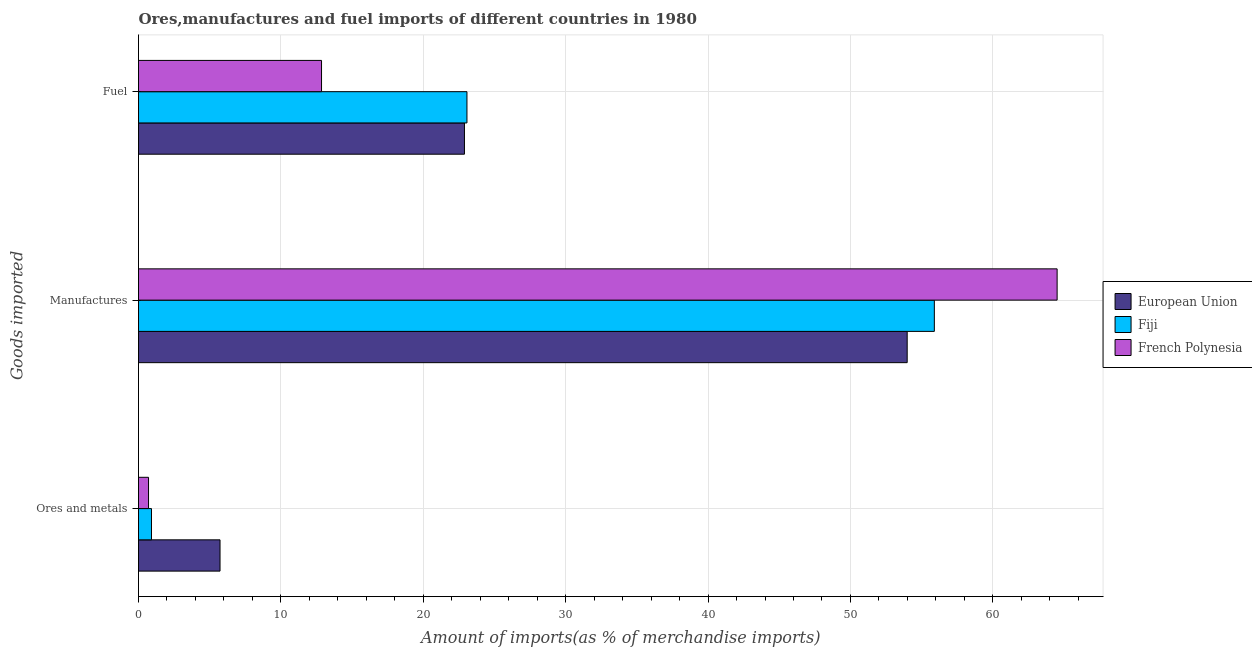How many groups of bars are there?
Your answer should be very brief. 3. Are the number of bars per tick equal to the number of legend labels?
Offer a very short reply. Yes. What is the label of the 3rd group of bars from the top?
Your answer should be very brief. Ores and metals. What is the percentage of fuel imports in Fiji?
Ensure brevity in your answer.  23.07. Across all countries, what is the maximum percentage of ores and metals imports?
Offer a terse response. 5.72. Across all countries, what is the minimum percentage of ores and metals imports?
Provide a succinct answer. 0.7. In which country was the percentage of ores and metals imports maximum?
Provide a succinct answer. European Union. What is the total percentage of manufactures imports in the graph?
Provide a succinct answer. 174.39. What is the difference between the percentage of fuel imports in European Union and that in Fiji?
Give a very brief answer. -0.18. What is the difference between the percentage of fuel imports in European Union and the percentage of ores and metals imports in Fiji?
Your answer should be very brief. 21.98. What is the average percentage of ores and metals imports per country?
Offer a terse response. 2.45. What is the difference between the percentage of ores and metals imports and percentage of manufactures imports in Fiji?
Make the answer very short. -54.98. What is the ratio of the percentage of manufactures imports in Fiji to that in French Polynesia?
Offer a terse response. 0.87. Is the percentage of manufactures imports in French Polynesia less than that in European Union?
Your answer should be very brief. No. Is the difference between the percentage of manufactures imports in French Polynesia and Fiji greater than the difference between the percentage of ores and metals imports in French Polynesia and Fiji?
Offer a terse response. Yes. What is the difference between the highest and the second highest percentage of fuel imports?
Your response must be concise. 0.18. What is the difference between the highest and the lowest percentage of ores and metals imports?
Your answer should be very brief. 5.02. In how many countries, is the percentage of manufactures imports greater than the average percentage of manufactures imports taken over all countries?
Give a very brief answer. 1. Is the sum of the percentage of fuel imports in European Union and French Polynesia greater than the maximum percentage of ores and metals imports across all countries?
Provide a succinct answer. Yes. What does the 2nd bar from the top in Fuel represents?
Offer a very short reply. Fiji. What does the 2nd bar from the bottom in Ores and metals represents?
Give a very brief answer. Fiji. Is it the case that in every country, the sum of the percentage of ores and metals imports and percentage of manufactures imports is greater than the percentage of fuel imports?
Your answer should be very brief. Yes. How many bars are there?
Make the answer very short. 9. Are the values on the major ticks of X-axis written in scientific E-notation?
Make the answer very short. No. Does the graph contain any zero values?
Offer a terse response. No. Where does the legend appear in the graph?
Give a very brief answer. Center right. How many legend labels are there?
Your answer should be very brief. 3. What is the title of the graph?
Keep it short and to the point. Ores,manufactures and fuel imports of different countries in 1980. Does "Dominican Republic" appear as one of the legend labels in the graph?
Your response must be concise. No. What is the label or title of the X-axis?
Give a very brief answer. Amount of imports(as % of merchandise imports). What is the label or title of the Y-axis?
Your answer should be very brief. Goods imported. What is the Amount of imports(as % of merchandise imports) in European Union in Ores and metals?
Your answer should be very brief. 5.72. What is the Amount of imports(as % of merchandise imports) of Fiji in Ores and metals?
Offer a terse response. 0.91. What is the Amount of imports(as % of merchandise imports) of French Polynesia in Ores and metals?
Your answer should be very brief. 0.7. What is the Amount of imports(as % of merchandise imports) of European Union in Manufactures?
Make the answer very short. 53.98. What is the Amount of imports(as % of merchandise imports) in Fiji in Manufactures?
Offer a very short reply. 55.89. What is the Amount of imports(as % of merchandise imports) in French Polynesia in Manufactures?
Ensure brevity in your answer.  64.51. What is the Amount of imports(as % of merchandise imports) of European Union in Fuel?
Your answer should be very brief. 22.89. What is the Amount of imports(as % of merchandise imports) in Fiji in Fuel?
Give a very brief answer. 23.07. What is the Amount of imports(as % of merchandise imports) of French Polynesia in Fuel?
Make the answer very short. 12.85. Across all Goods imported, what is the maximum Amount of imports(as % of merchandise imports) of European Union?
Offer a terse response. 53.98. Across all Goods imported, what is the maximum Amount of imports(as % of merchandise imports) of Fiji?
Provide a short and direct response. 55.89. Across all Goods imported, what is the maximum Amount of imports(as % of merchandise imports) of French Polynesia?
Keep it short and to the point. 64.51. Across all Goods imported, what is the minimum Amount of imports(as % of merchandise imports) in European Union?
Give a very brief answer. 5.72. Across all Goods imported, what is the minimum Amount of imports(as % of merchandise imports) in Fiji?
Your response must be concise. 0.91. Across all Goods imported, what is the minimum Amount of imports(as % of merchandise imports) in French Polynesia?
Offer a very short reply. 0.7. What is the total Amount of imports(as % of merchandise imports) of European Union in the graph?
Offer a terse response. 82.6. What is the total Amount of imports(as % of merchandise imports) of Fiji in the graph?
Give a very brief answer. 79.87. What is the total Amount of imports(as % of merchandise imports) in French Polynesia in the graph?
Your answer should be compact. 78.07. What is the difference between the Amount of imports(as % of merchandise imports) in European Union in Ores and metals and that in Manufactures?
Your answer should be compact. -48.26. What is the difference between the Amount of imports(as % of merchandise imports) in Fiji in Ores and metals and that in Manufactures?
Provide a short and direct response. -54.98. What is the difference between the Amount of imports(as % of merchandise imports) in French Polynesia in Ores and metals and that in Manufactures?
Provide a succinct answer. -63.81. What is the difference between the Amount of imports(as % of merchandise imports) of European Union in Ores and metals and that in Fuel?
Keep it short and to the point. -17.17. What is the difference between the Amount of imports(as % of merchandise imports) in Fiji in Ores and metals and that in Fuel?
Make the answer very short. -22.16. What is the difference between the Amount of imports(as % of merchandise imports) in French Polynesia in Ores and metals and that in Fuel?
Your answer should be compact. -12.15. What is the difference between the Amount of imports(as % of merchandise imports) in European Union in Manufactures and that in Fuel?
Offer a terse response. 31.09. What is the difference between the Amount of imports(as % of merchandise imports) of Fiji in Manufactures and that in Fuel?
Give a very brief answer. 32.82. What is the difference between the Amount of imports(as % of merchandise imports) in French Polynesia in Manufactures and that in Fuel?
Provide a short and direct response. 51.66. What is the difference between the Amount of imports(as % of merchandise imports) of European Union in Ores and metals and the Amount of imports(as % of merchandise imports) of Fiji in Manufactures?
Your response must be concise. -50.17. What is the difference between the Amount of imports(as % of merchandise imports) in European Union in Ores and metals and the Amount of imports(as % of merchandise imports) in French Polynesia in Manufactures?
Your response must be concise. -58.79. What is the difference between the Amount of imports(as % of merchandise imports) in Fiji in Ores and metals and the Amount of imports(as % of merchandise imports) in French Polynesia in Manufactures?
Offer a terse response. -63.6. What is the difference between the Amount of imports(as % of merchandise imports) of European Union in Ores and metals and the Amount of imports(as % of merchandise imports) of Fiji in Fuel?
Offer a terse response. -17.34. What is the difference between the Amount of imports(as % of merchandise imports) in European Union in Ores and metals and the Amount of imports(as % of merchandise imports) in French Polynesia in Fuel?
Provide a short and direct response. -7.13. What is the difference between the Amount of imports(as % of merchandise imports) of Fiji in Ores and metals and the Amount of imports(as % of merchandise imports) of French Polynesia in Fuel?
Give a very brief answer. -11.94. What is the difference between the Amount of imports(as % of merchandise imports) in European Union in Manufactures and the Amount of imports(as % of merchandise imports) in Fiji in Fuel?
Your answer should be compact. 30.92. What is the difference between the Amount of imports(as % of merchandise imports) of European Union in Manufactures and the Amount of imports(as % of merchandise imports) of French Polynesia in Fuel?
Offer a terse response. 41.13. What is the difference between the Amount of imports(as % of merchandise imports) of Fiji in Manufactures and the Amount of imports(as % of merchandise imports) of French Polynesia in Fuel?
Your response must be concise. 43.04. What is the average Amount of imports(as % of merchandise imports) in European Union per Goods imported?
Your response must be concise. 27.53. What is the average Amount of imports(as % of merchandise imports) of Fiji per Goods imported?
Keep it short and to the point. 26.62. What is the average Amount of imports(as % of merchandise imports) of French Polynesia per Goods imported?
Give a very brief answer. 26.02. What is the difference between the Amount of imports(as % of merchandise imports) of European Union and Amount of imports(as % of merchandise imports) of Fiji in Ores and metals?
Ensure brevity in your answer.  4.81. What is the difference between the Amount of imports(as % of merchandise imports) in European Union and Amount of imports(as % of merchandise imports) in French Polynesia in Ores and metals?
Ensure brevity in your answer.  5.02. What is the difference between the Amount of imports(as % of merchandise imports) of Fiji and Amount of imports(as % of merchandise imports) of French Polynesia in Ores and metals?
Offer a terse response. 0.21. What is the difference between the Amount of imports(as % of merchandise imports) of European Union and Amount of imports(as % of merchandise imports) of Fiji in Manufactures?
Your answer should be very brief. -1.91. What is the difference between the Amount of imports(as % of merchandise imports) of European Union and Amount of imports(as % of merchandise imports) of French Polynesia in Manufactures?
Keep it short and to the point. -10.53. What is the difference between the Amount of imports(as % of merchandise imports) of Fiji and Amount of imports(as % of merchandise imports) of French Polynesia in Manufactures?
Offer a terse response. -8.62. What is the difference between the Amount of imports(as % of merchandise imports) in European Union and Amount of imports(as % of merchandise imports) in Fiji in Fuel?
Your response must be concise. -0.18. What is the difference between the Amount of imports(as % of merchandise imports) of European Union and Amount of imports(as % of merchandise imports) of French Polynesia in Fuel?
Provide a short and direct response. 10.04. What is the difference between the Amount of imports(as % of merchandise imports) in Fiji and Amount of imports(as % of merchandise imports) in French Polynesia in Fuel?
Ensure brevity in your answer.  10.21. What is the ratio of the Amount of imports(as % of merchandise imports) of European Union in Ores and metals to that in Manufactures?
Ensure brevity in your answer.  0.11. What is the ratio of the Amount of imports(as % of merchandise imports) of Fiji in Ores and metals to that in Manufactures?
Keep it short and to the point. 0.02. What is the ratio of the Amount of imports(as % of merchandise imports) of French Polynesia in Ores and metals to that in Manufactures?
Ensure brevity in your answer.  0.01. What is the ratio of the Amount of imports(as % of merchandise imports) of European Union in Ores and metals to that in Fuel?
Offer a very short reply. 0.25. What is the ratio of the Amount of imports(as % of merchandise imports) of Fiji in Ores and metals to that in Fuel?
Ensure brevity in your answer.  0.04. What is the ratio of the Amount of imports(as % of merchandise imports) in French Polynesia in Ores and metals to that in Fuel?
Provide a succinct answer. 0.05. What is the ratio of the Amount of imports(as % of merchandise imports) in European Union in Manufactures to that in Fuel?
Give a very brief answer. 2.36. What is the ratio of the Amount of imports(as % of merchandise imports) of Fiji in Manufactures to that in Fuel?
Give a very brief answer. 2.42. What is the ratio of the Amount of imports(as % of merchandise imports) of French Polynesia in Manufactures to that in Fuel?
Your answer should be very brief. 5.02. What is the difference between the highest and the second highest Amount of imports(as % of merchandise imports) of European Union?
Your response must be concise. 31.09. What is the difference between the highest and the second highest Amount of imports(as % of merchandise imports) in Fiji?
Your response must be concise. 32.82. What is the difference between the highest and the second highest Amount of imports(as % of merchandise imports) of French Polynesia?
Provide a short and direct response. 51.66. What is the difference between the highest and the lowest Amount of imports(as % of merchandise imports) in European Union?
Make the answer very short. 48.26. What is the difference between the highest and the lowest Amount of imports(as % of merchandise imports) in Fiji?
Your answer should be very brief. 54.98. What is the difference between the highest and the lowest Amount of imports(as % of merchandise imports) in French Polynesia?
Provide a succinct answer. 63.81. 